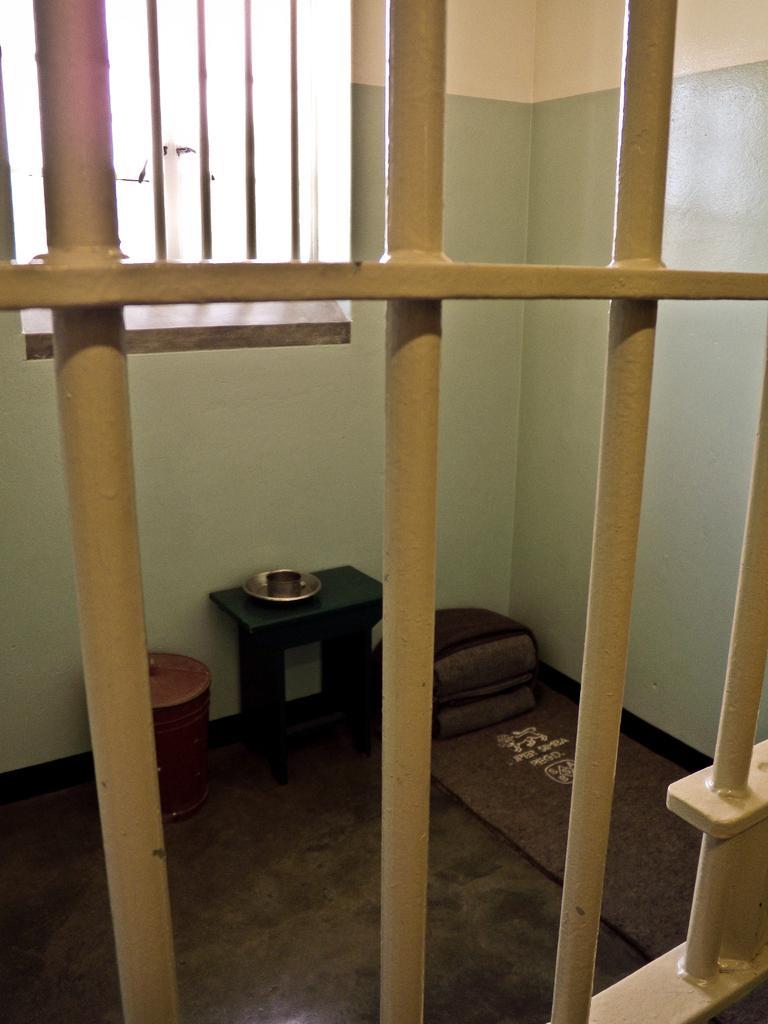In one or two sentences, can you explain what this image depicts? In this picture there is an iron fence which is in yellow color and there is a table which has few objects placed on it and there is a dustbin beside it and there are few objects in the right corner and there is a window in the background. 